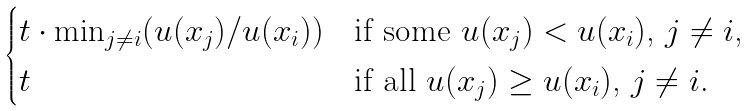<formula> <loc_0><loc_0><loc_500><loc_500>\begin{cases} t \cdot \min _ { j \neq i } ( u ( x _ { j } ) / u ( x _ { i } ) ) & \text {if some $u(x_{j}) < u(x_{i})$, $j \neq i$,} \\ t & \text {if all $u(x_{j}) \geq u(x_{i})$, $j \neq i$.} \end{cases}</formula> 